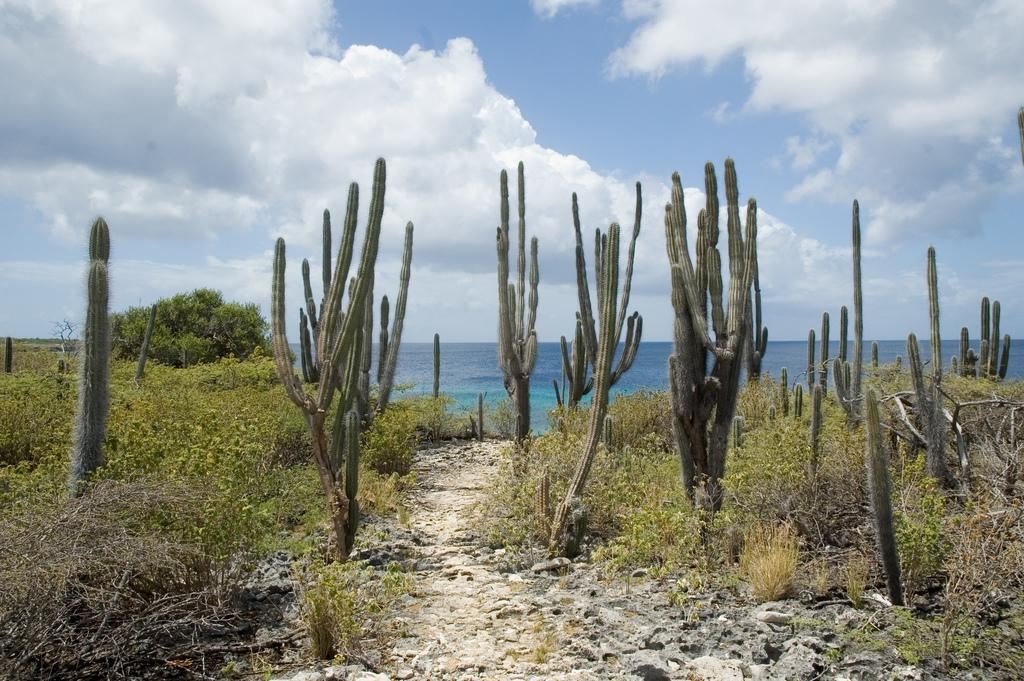What type of plants can be seen in the image? There are many cactus plants in the image. What natural feature can be seen in the background of the image? The ocean is visible in the background of the image. What type of vegetation is on the left side of the image? There are trees, plants, and grass on the left side of the image. What is visible at the top of the image? The sky is visible at the top of the image. What can be seen in the sky in the image? Clouds are present in the sky. How many boys are visible in the image? There are no boys present in the image. Is there a window visible in the image? There is no window present in the image. Can you see any mice in the image? There are no mice present in the image. 